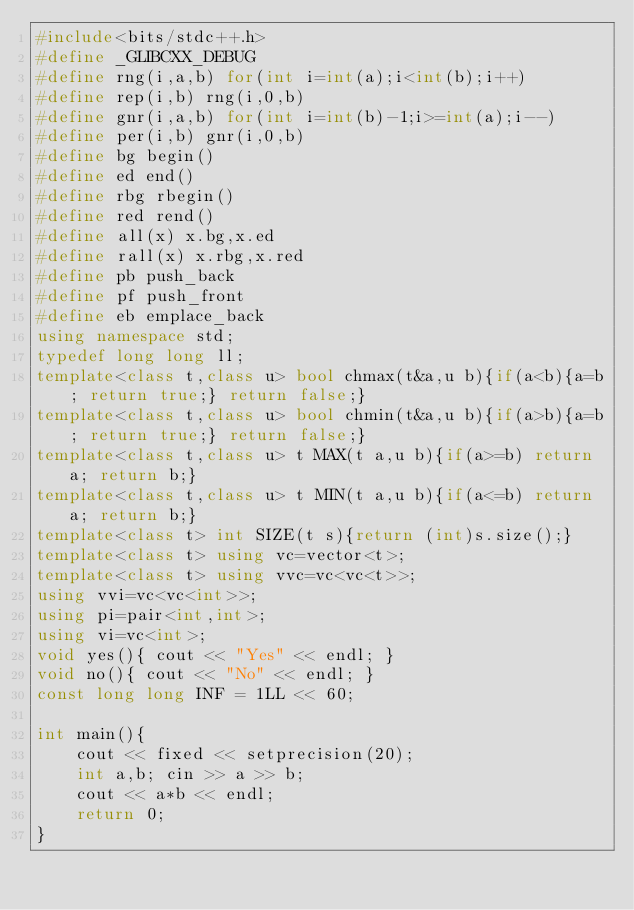Convert code to text. <code><loc_0><loc_0><loc_500><loc_500><_C++_>#include<bits/stdc++.h>
#define _GLIBCXX_DEBUG
#define rng(i,a,b) for(int i=int(a);i<int(b);i++)
#define rep(i,b) rng(i,0,b)
#define gnr(i,a,b) for(int i=int(b)-1;i>=int(a);i--)
#define per(i,b) gnr(i,0,b)
#define bg begin()
#define ed end()
#define rbg rbegin()
#define red rend()
#define all(x) x.bg,x.ed
#define rall(x) x.rbg,x.red
#define pb push_back
#define pf push_front
#define eb emplace_back
using namespace std;
typedef long long ll;
template<class t,class u> bool chmax(t&a,u b){if(a<b){a=b; return true;} return false;}
template<class t,class u> bool chmin(t&a,u b){if(a>b){a=b; return true;} return false;}
template<class t,class u> t MAX(t a,u b){if(a>=b) return a; return b;}
template<class t,class u> t MIN(t a,u b){if(a<=b) return a; return b;}
template<class t> int SIZE(t s){return (int)s.size();}
template<class t> using vc=vector<t>;
template<class t> using vvc=vc<vc<t>>;
using vvi=vc<vc<int>>;
using pi=pair<int,int>;
using vi=vc<int>;
void yes(){ cout << "Yes" << endl; }
void no(){ cout << "No" << endl; }
const long long INF = 1LL << 60;

int main(){
    cout << fixed << setprecision(20);
    int a,b; cin >> a >> b;
    cout << a*b << endl;
    return 0;
}
</code> 